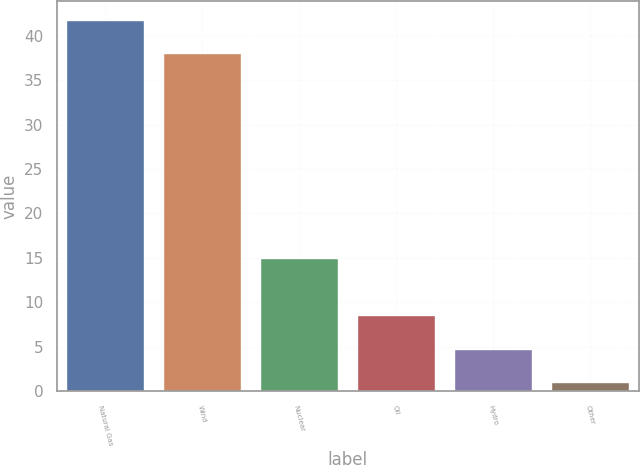Convert chart to OTSL. <chart><loc_0><loc_0><loc_500><loc_500><bar_chart><fcel>Natural Gas<fcel>Wind<fcel>Nuclear<fcel>Oil<fcel>Hydro<fcel>Other<nl><fcel>41.8<fcel>38<fcel>15<fcel>8.6<fcel>4.8<fcel>1<nl></chart> 